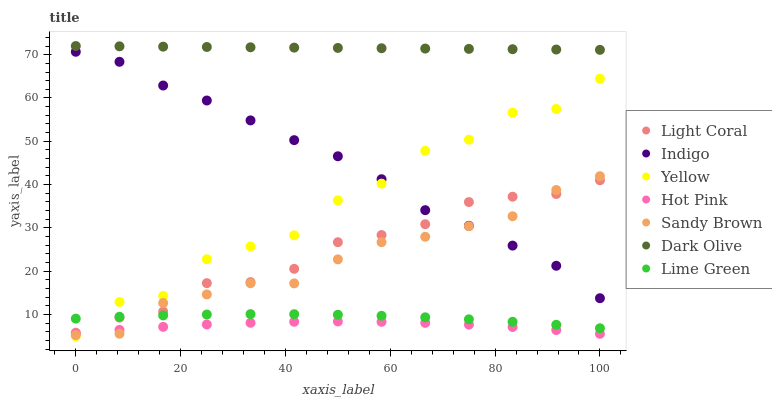Does Hot Pink have the minimum area under the curve?
Answer yes or no. Yes. Does Dark Olive have the maximum area under the curve?
Answer yes or no. Yes. Does Indigo have the minimum area under the curve?
Answer yes or no. No. Does Indigo have the maximum area under the curve?
Answer yes or no. No. Is Dark Olive the smoothest?
Answer yes or no. Yes. Is Yellow the roughest?
Answer yes or no. Yes. Is Indigo the smoothest?
Answer yes or no. No. Is Indigo the roughest?
Answer yes or no. No. Does Yellow have the lowest value?
Answer yes or no. Yes. Does Indigo have the lowest value?
Answer yes or no. No. Does Dark Olive have the highest value?
Answer yes or no. Yes. Does Indigo have the highest value?
Answer yes or no. No. Is Light Coral less than Dark Olive?
Answer yes or no. Yes. Is Lime Green greater than Hot Pink?
Answer yes or no. Yes. Does Hot Pink intersect Yellow?
Answer yes or no. Yes. Is Hot Pink less than Yellow?
Answer yes or no. No. Is Hot Pink greater than Yellow?
Answer yes or no. No. Does Light Coral intersect Dark Olive?
Answer yes or no. No. 